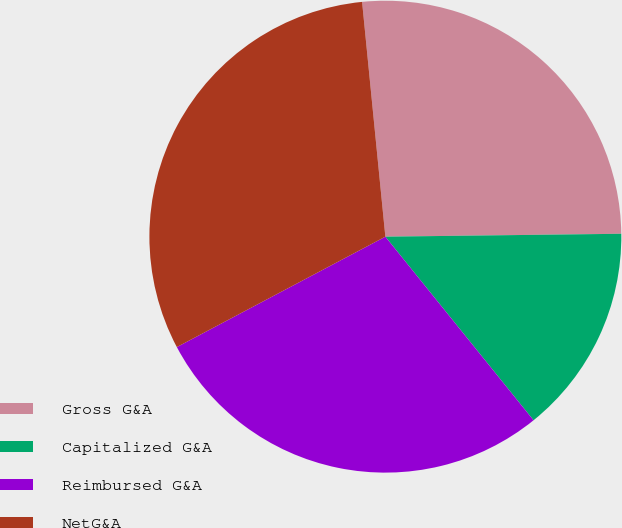Convert chart. <chart><loc_0><loc_0><loc_500><loc_500><pie_chart><fcel>Gross G&A<fcel>Capitalized G&A<fcel>Reimbursed G&A<fcel>NetG&A<nl><fcel>26.38%<fcel>14.39%<fcel>28.06%<fcel>31.18%<nl></chart> 